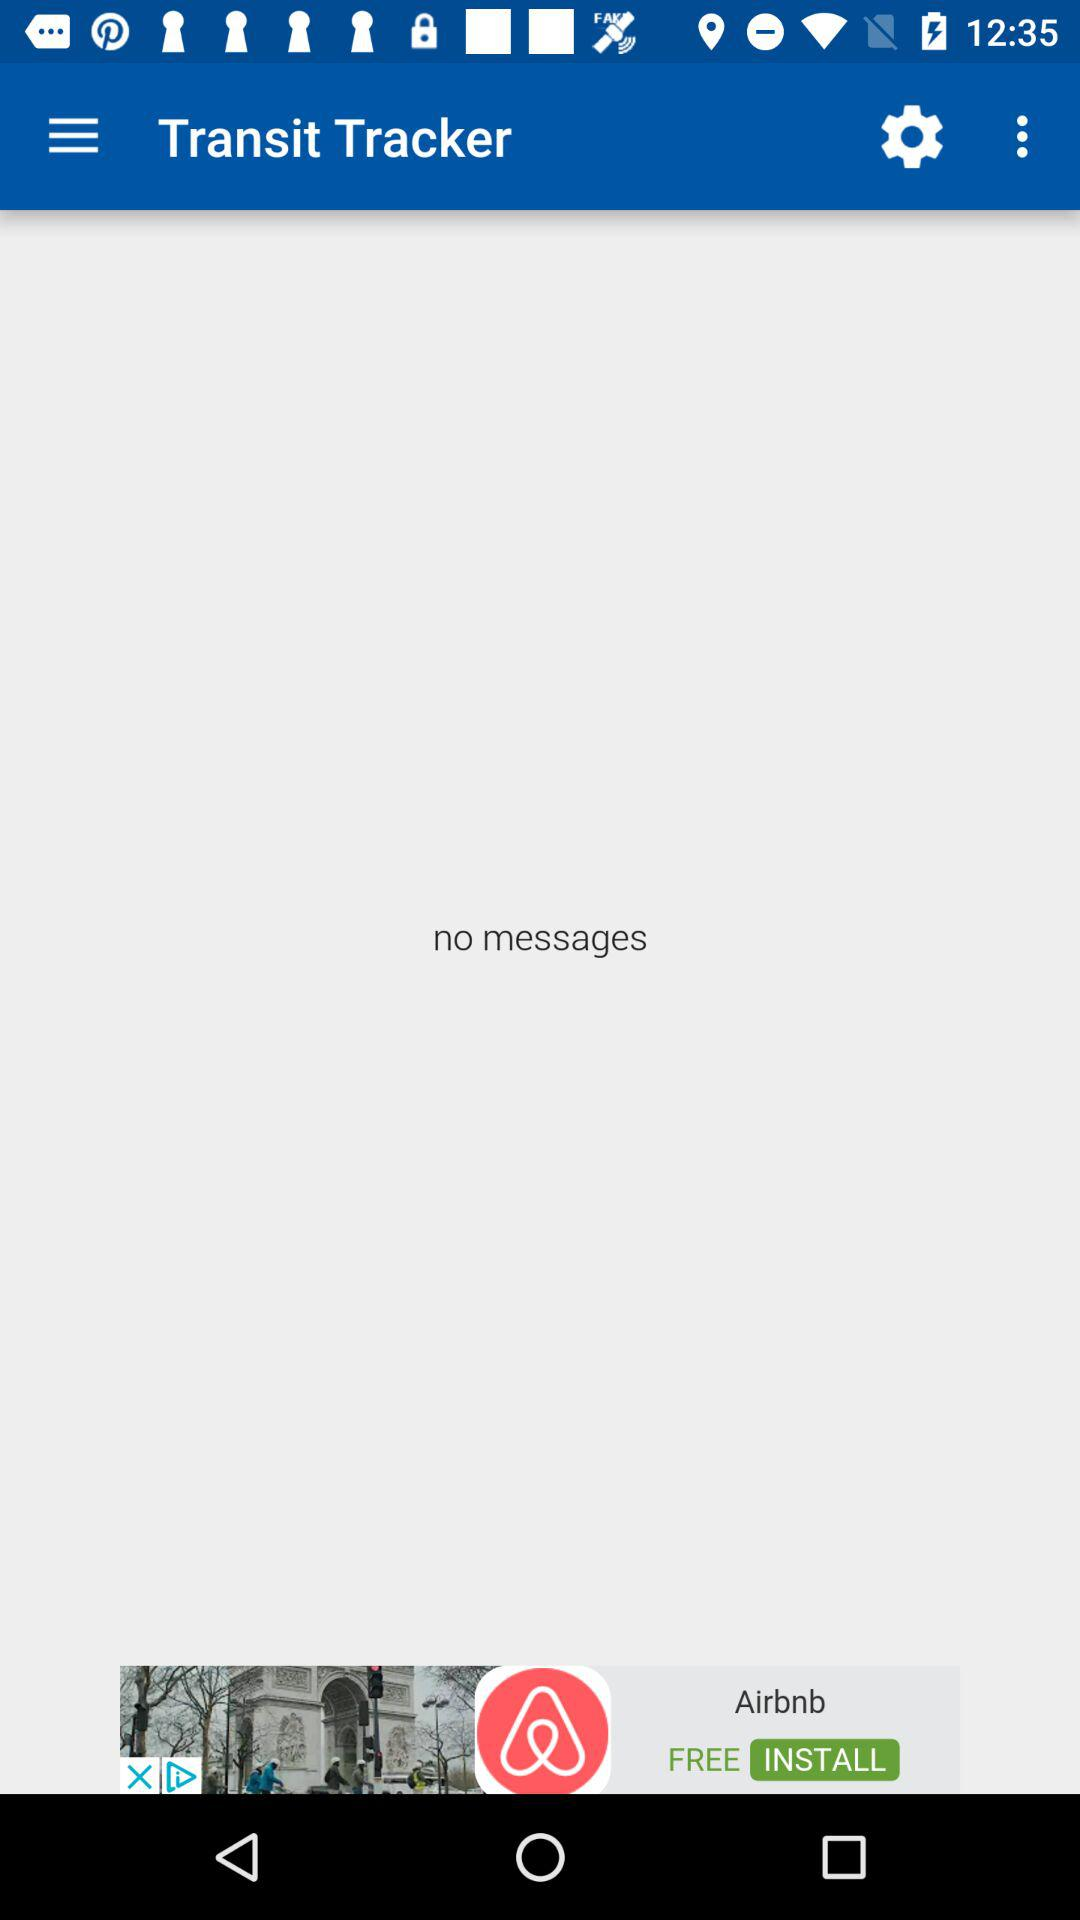Are there any messages? There are no messages. 